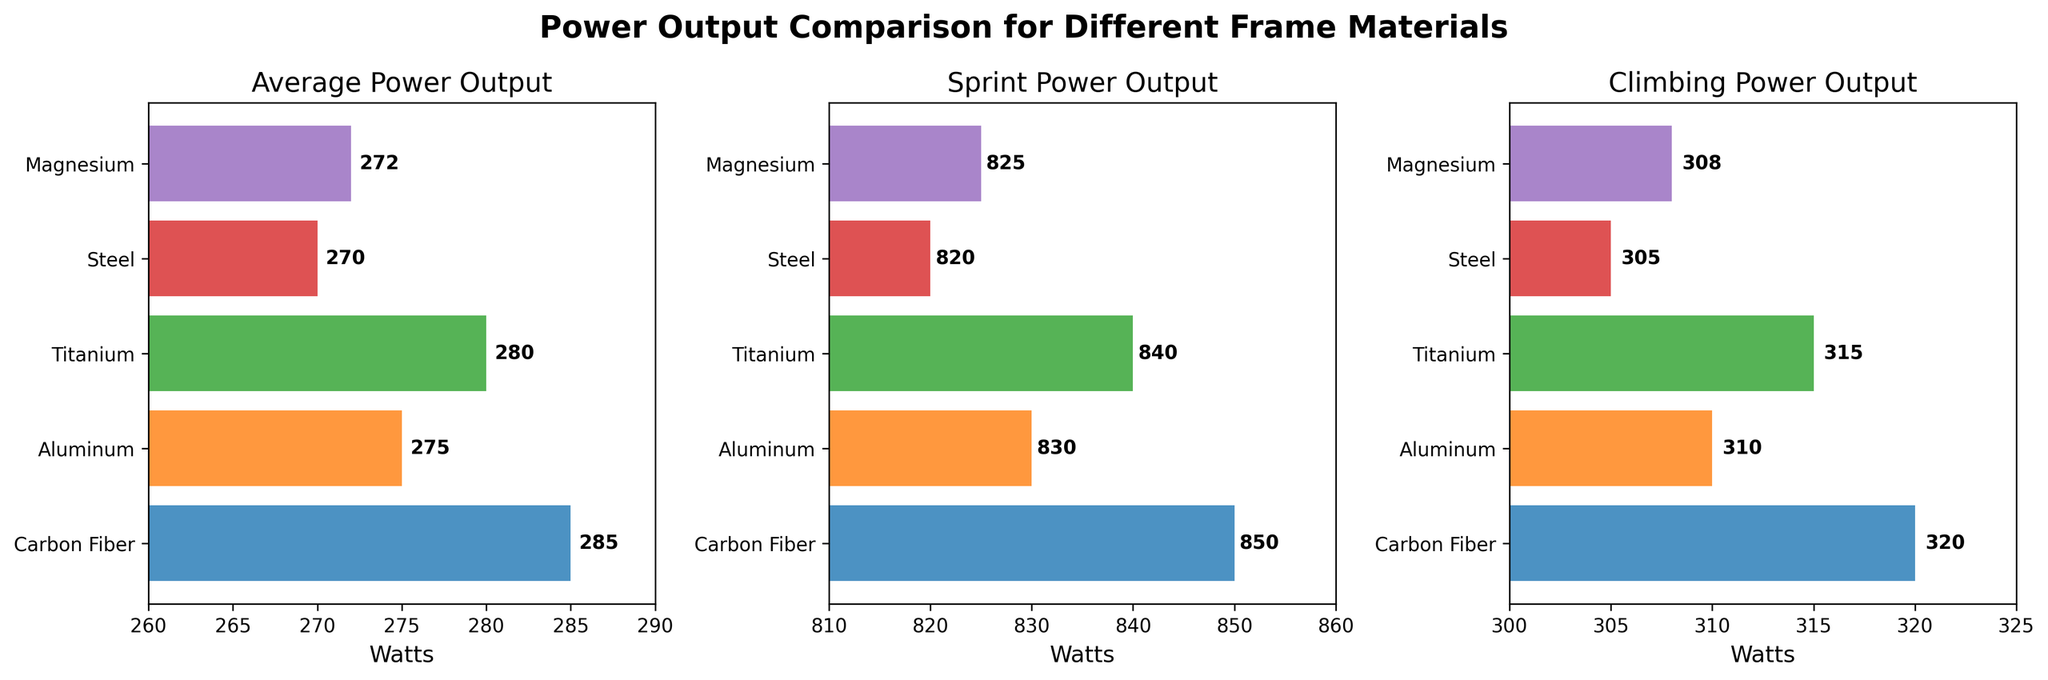What is the average power output for Titanium frames? The bar labeled "Titanium" in the "Average Power Output" subplot shows a value of 280 watts.
Answer: 280 watts Which frame material has the highest sprint power output? In the "Sprint Power Output" subplot, the tallest bar corresponds to "Carbon Fiber" with a value of 850 watts.
Answer: Carbon Fiber What is the difference between the climbing power output of Steel and Aluminum frames? The "Climbing Power Output" subplot shows 305 watts for Steel and 310 watts for Aluminum. The difference is 310 - 305 = 5 watts.
Answer: 5 watts Which frame material has the lowest average power output? In the "Average Power Output" subplot, the shortest bar corresponds to "Steel," which shows a value of 270 watts.
Answer: Steel How much higher is the sprint power output of Carbon Fiber compared to Magnesium? The "Sprint Power Output" subplot shows 850 watts for Carbon Fiber and 825 watts for Magnesium. The difference is 850 - 825 = 25 watts.
Answer: 25 watts What is the average of the average power outputs for all frame materials? Add the average power outputs (285 + 275 + 280 + 270 + 272 = 1382) and divide by the number of frame materials (5), so the average is 1382/5 = 276.4 watts.
Answer: 276.4 watts Which frame materials have an average power output greater than 275 watts? In the "Average Power Output" subplot, the bars for Carbon Fiber (285), Titanium (280), and Aluminum (275) are all greater than 275 watts.
Answer: Carbon Fiber, Titanium What is the combined power output for Climbing and Sprint for Magnesium frames? The "Climbing Power Output" and "Sprint Power Output" subplots show values of 308 and 825 watts respectively for Magnesium. The sum is 308 + 825 = 1133 watts.
Answer: 1133 watts Among the frame materials shown, which has the second lowest climbing power output? The "Climbing Power Output" subplot shows values of 320 (Carbon Fiber), 310 (Aluminum), 315 (Titanium), 305 (Steel), and 308 (Magnesium). The second lowest is Magnesium with 308 watts.
Answer: Magnesium What is the range of sprint power outputs across all frame materials? The "Sprint Power Output" subplot shows values from 820 (Steel) to 850 (Carbon Fiber). The range is 850 - 820 = 30 watts.
Answer: 30 watts 